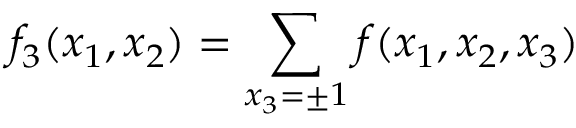<formula> <loc_0><loc_0><loc_500><loc_500>f _ { 3 } ( x _ { 1 } , x _ { 2 } ) = \sum _ { x _ { 3 } = \pm 1 } f ( x _ { 1 } , x _ { 2 } , x _ { 3 } )</formula> 